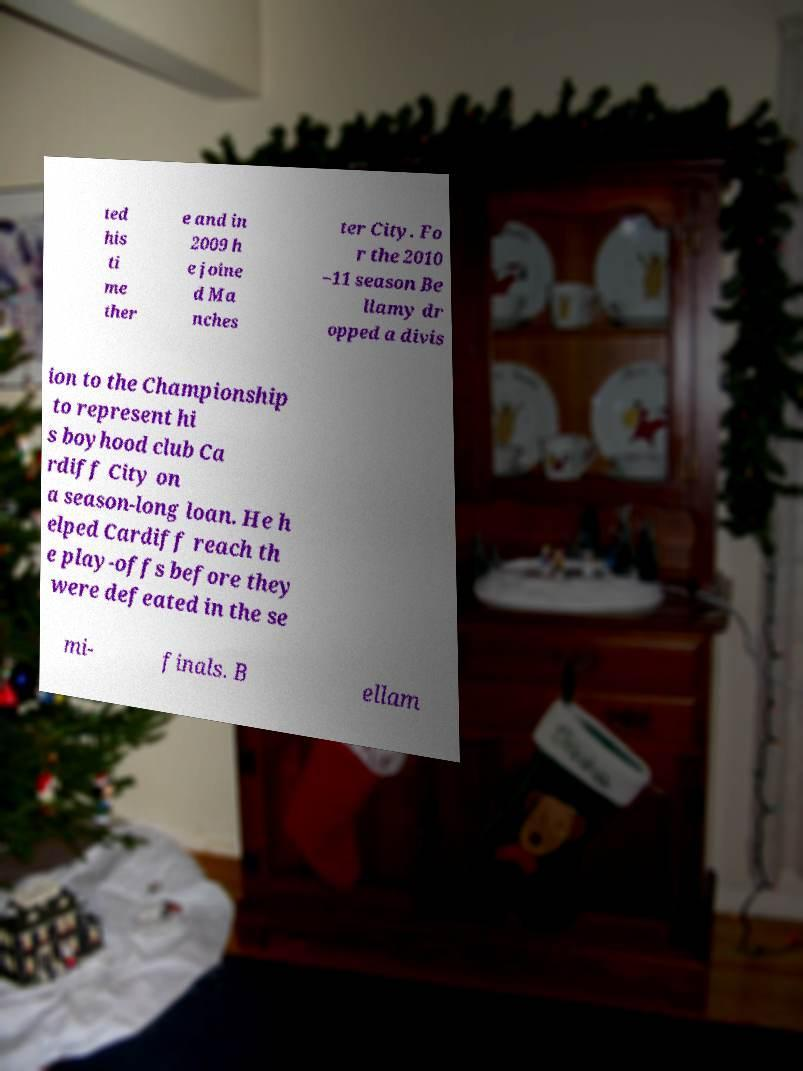Can you accurately transcribe the text from the provided image for me? ted his ti me ther e and in 2009 h e joine d Ma nches ter City. Fo r the 2010 –11 season Be llamy dr opped a divis ion to the Championship to represent hi s boyhood club Ca rdiff City on a season-long loan. He h elped Cardiff reach th e play-offs before they were defeated in the se mi- finals. B ellam 